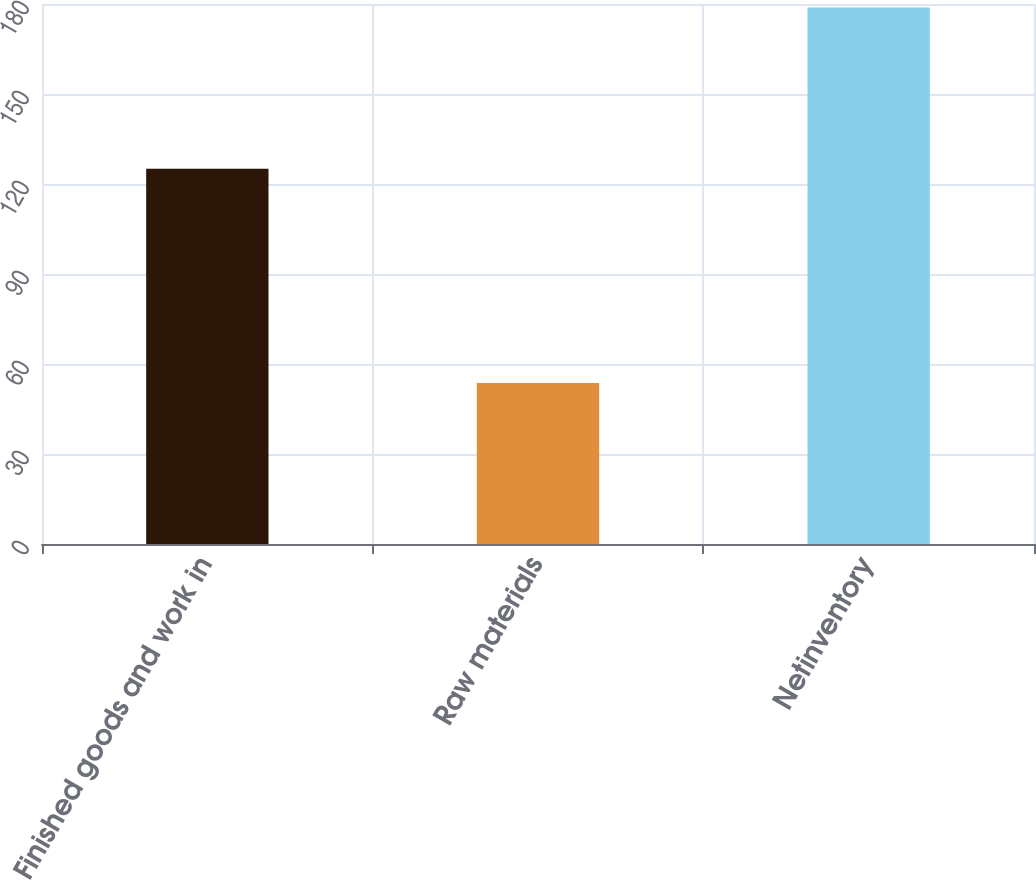Convert chart to OTSL. <chart><loc_0><loc_0><loc_500><loc_500><bar_chart><fcel>Finished goods and work in<fcel>Raw materials<fcel>Netinventory<nl><fcel>125.1<fcel>53.7<fcel>178.8<nl></chart> 